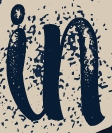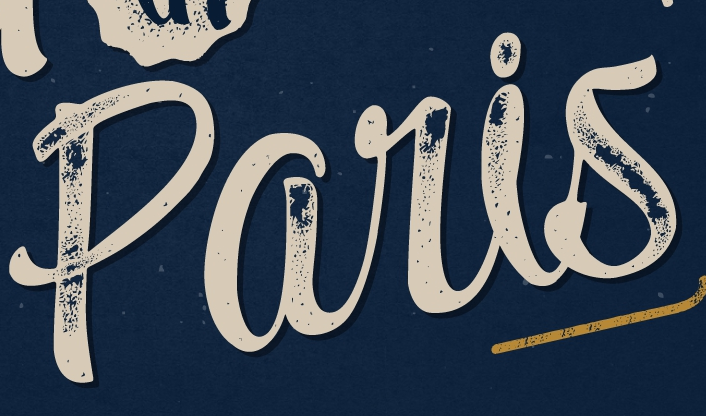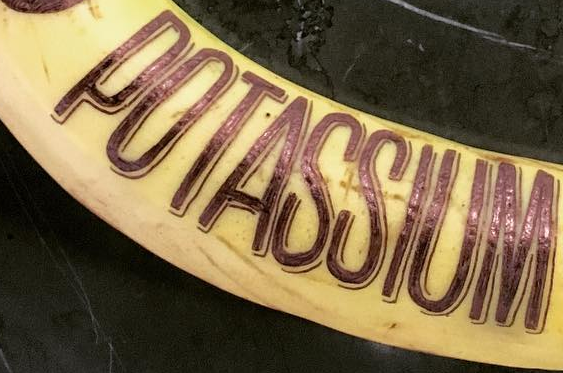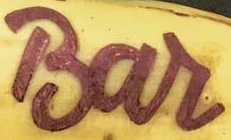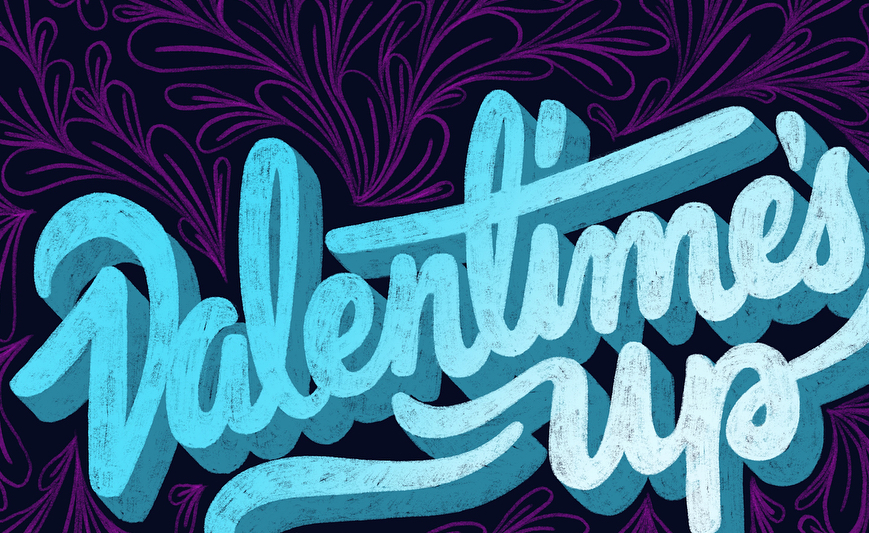What words are shown in these images in order, separated by a semicolon? in; paris; POTASSIUM; Bar; Valentime's 